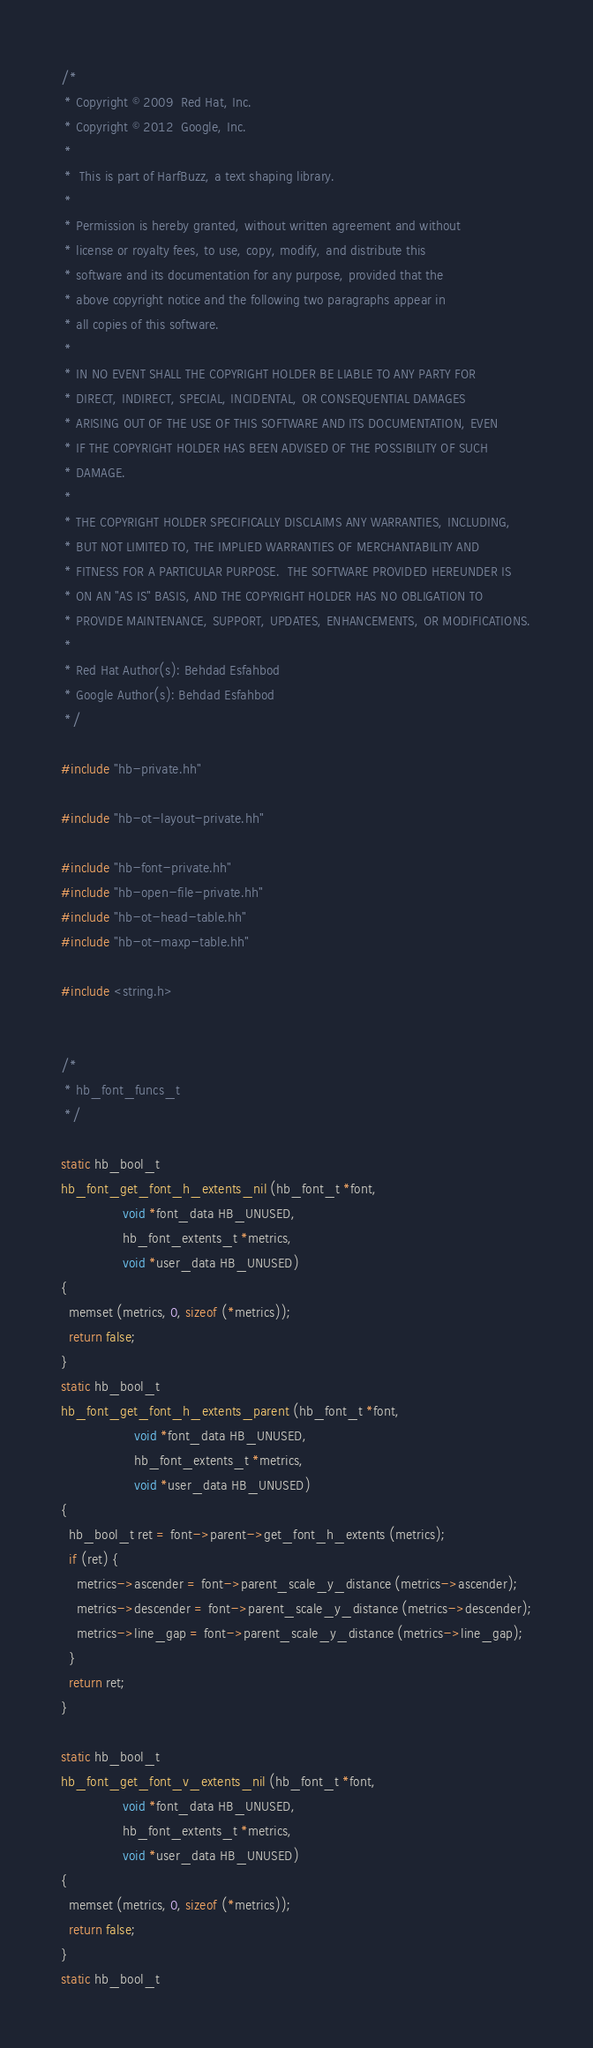<code> <loc_0><loc_0><loc_500><loc_500><_C++_>/*
 * Copyright © 2009  Red Hat, Inc.
 * Copyright © 2012  Google, Inc.
 *
 *  This is part of HarfBuzz, a text shaping library.
 *
 * Permission is hereby granted, without written agreement and without
 * license or royalty fees, to use, copy, modify, and distribute this
 * software and its documentation for any purpose, provided that the
 * above copyright notice and the following two paragraphs appear in
 * all copies of this software.
 *
 * IN NO EVENT SHALL THE COPYRIGHT HOLDER BE LIABLE TO ANY PARTY FOR
 * DIRECT, INDIRECT, SPECIAL, INCIDENTAL, OR CONSEQUENTIAL DAMAGES
 * ARISING OUT OF THE USE OF THIS SOFTWARE AND ITS DOCUMENTATION, EVEN
 * IF THE COPYRIGHT HOLDER HAS BEEN ADVISED OF THE POSSIBILITY OF SUCH
 * DAMAGE.
 *
 * THE COPYRIGHT HOLDER SPECIFICALLY DISCLAIMS ANY WARRANTIES, INCLUDING,
 * BUT NOT LIMITED TO, THE IMPLIED WARRANTIES OF MERCHANTABILITY AND
 * FITNESS FOR A PARTICULAR PURPOSE.  THE SOFTWARE PROVIDED HEREUNDER IS
 * ON AN "AS IS" BASIS, AND THE COPYRIGHT HOLDER HAS NO OBLIGATION TO
 * PROVIDE MAINTENANCE, SUPPORT, UPDATES, ENHANCEMENTS, OR MODIFICATIONS.
 *
 * Red Hat Author(s): Behdad Esfahbod
 * Google Author(s): Behdad Esfahbod
 */

#include "hb-private.hh"

#include "hb-ot-layout-private.hh"

#include "hb-font-private.hh"
#include "hb-open-file-private.hh"
#include "hb-ot-head-table.hh"
#include "hb-ot-maxp-table.hh"

#include <string.h>


/*
 * hb_font_funcs_t
 */

static hb_bool_t
hb_font_get_font_h_extents_nil (hb_font_t *font,
				void *font_data HB_UNUSED,
				hb_font_extents_t *metrics,
				void *user_data HB_UNUSED)
{
  memset (metrics, 0, sizeof (*metrics));
  return false;
}
static hb_bool_t
hb_font_get_font_h_extents_parent (hb_font_t *font,
				   void *font_data HB_UNUSED,
				   hb_font_extents_t *metrics,
				   void *user_data HB_UNUSED)
{
  hb_bool_t ret = font->parent->get_font_h_extents (metrics);
  if (ret) {
    metrics->ascender = font->parent_scale_y_distance (metrics->ascender);
    metrics->descender = font->parent_scale_y_distance (metrics->descender);
    metrics->line_gap = font->parent_scale_y_distance (metrics->line_gap);
  }
  return ret;
}

static hb_bool_t
hb_font_get_font_v_extents_nil (hb_font_t *font,
				void *font_data HB_UNUSED,
				hb_font_extents_t *metrics,
				void *user_data HB_UNUSED)
{
  memset (metrics, 0, sizeof (*metrics));
  return false;
}
static hb_bool_t</code> 